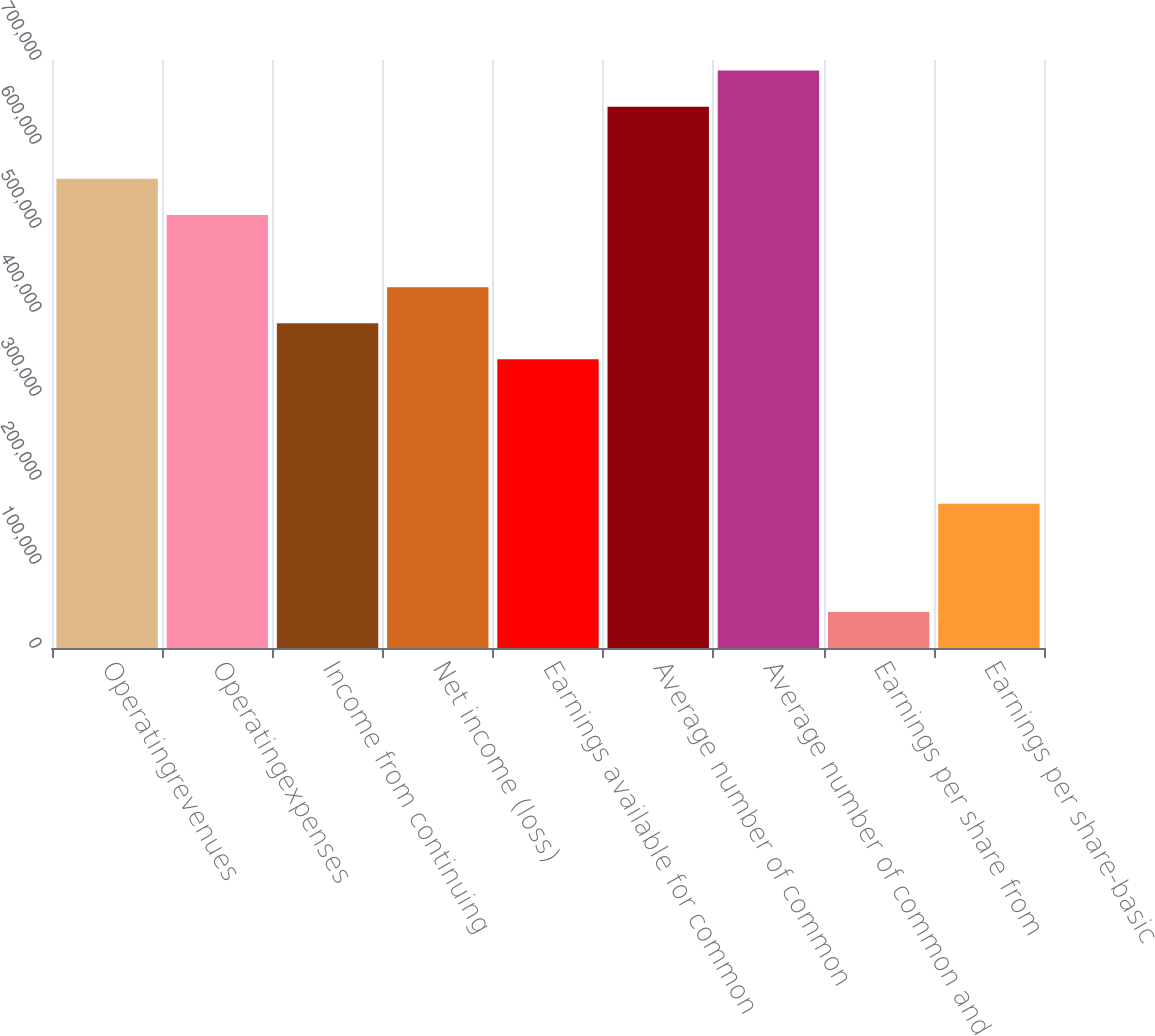Convert chart. <chart><loc_0><loc_0><loc_500><loc_500><bar_chart><fcel>Operatingrevenues<fcel>Operatingexpenses<fcel>Income from continuing<fcel>Net income (loss)<fcel>Earnings available for common<fcel>Average number of common<fcel>Average number of common and<fcel>Earnings per share from<fcel>Earnings per share-basic<nl><fcel>558486<fcel>515526<fcel>386645<fcel>429605<fcel>343684<fcel>644407<fcel>687367<fcel>42961.3<fcel>171843<nl></chart> 